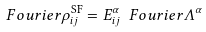<formula> <loc_0><loc_0><loc_500><loc_500>\ F o u r i e r { \rho } ^ { \text {SF} } _ { i j } = E ^ { \alpha } _ { i j } \ F o u r i e r { \Lambda } ^ { \alpha }</formula> 